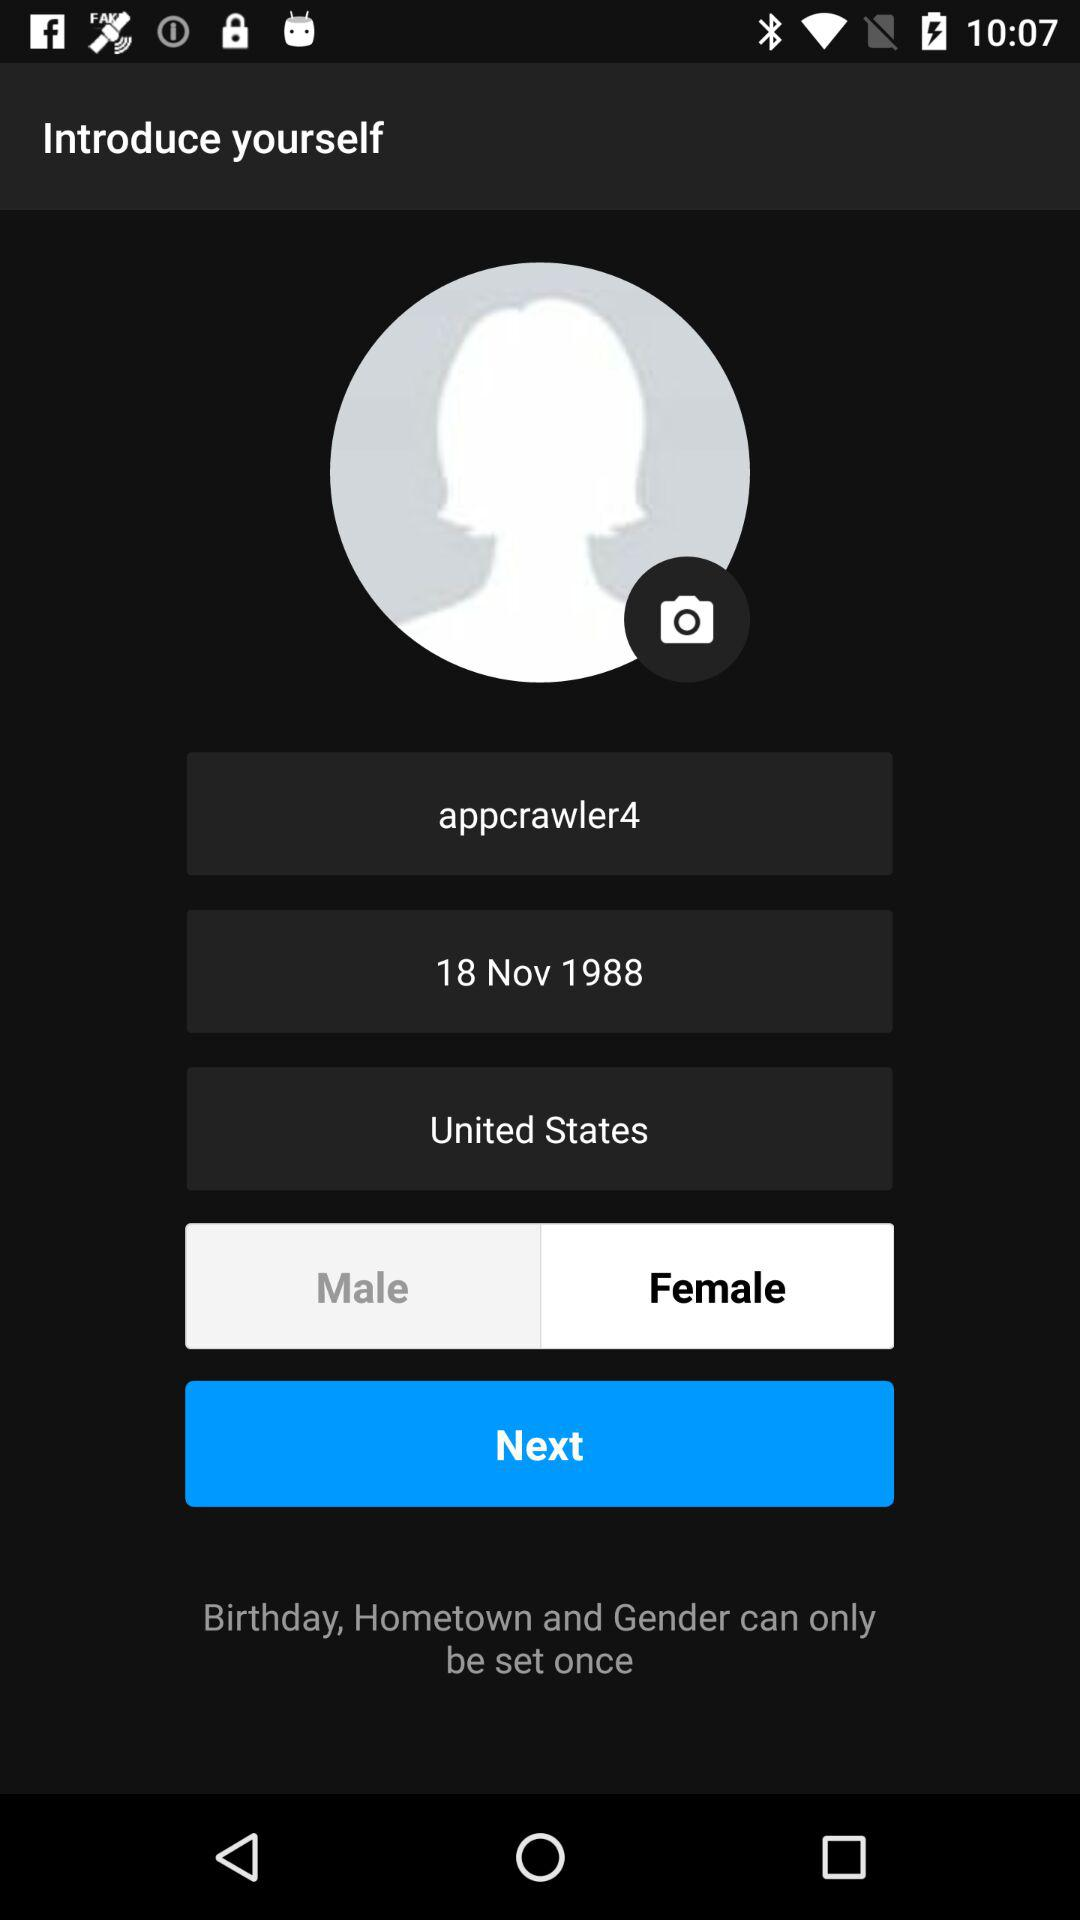How many gender options are available?
Answer the question using a single word or phrase. 2 